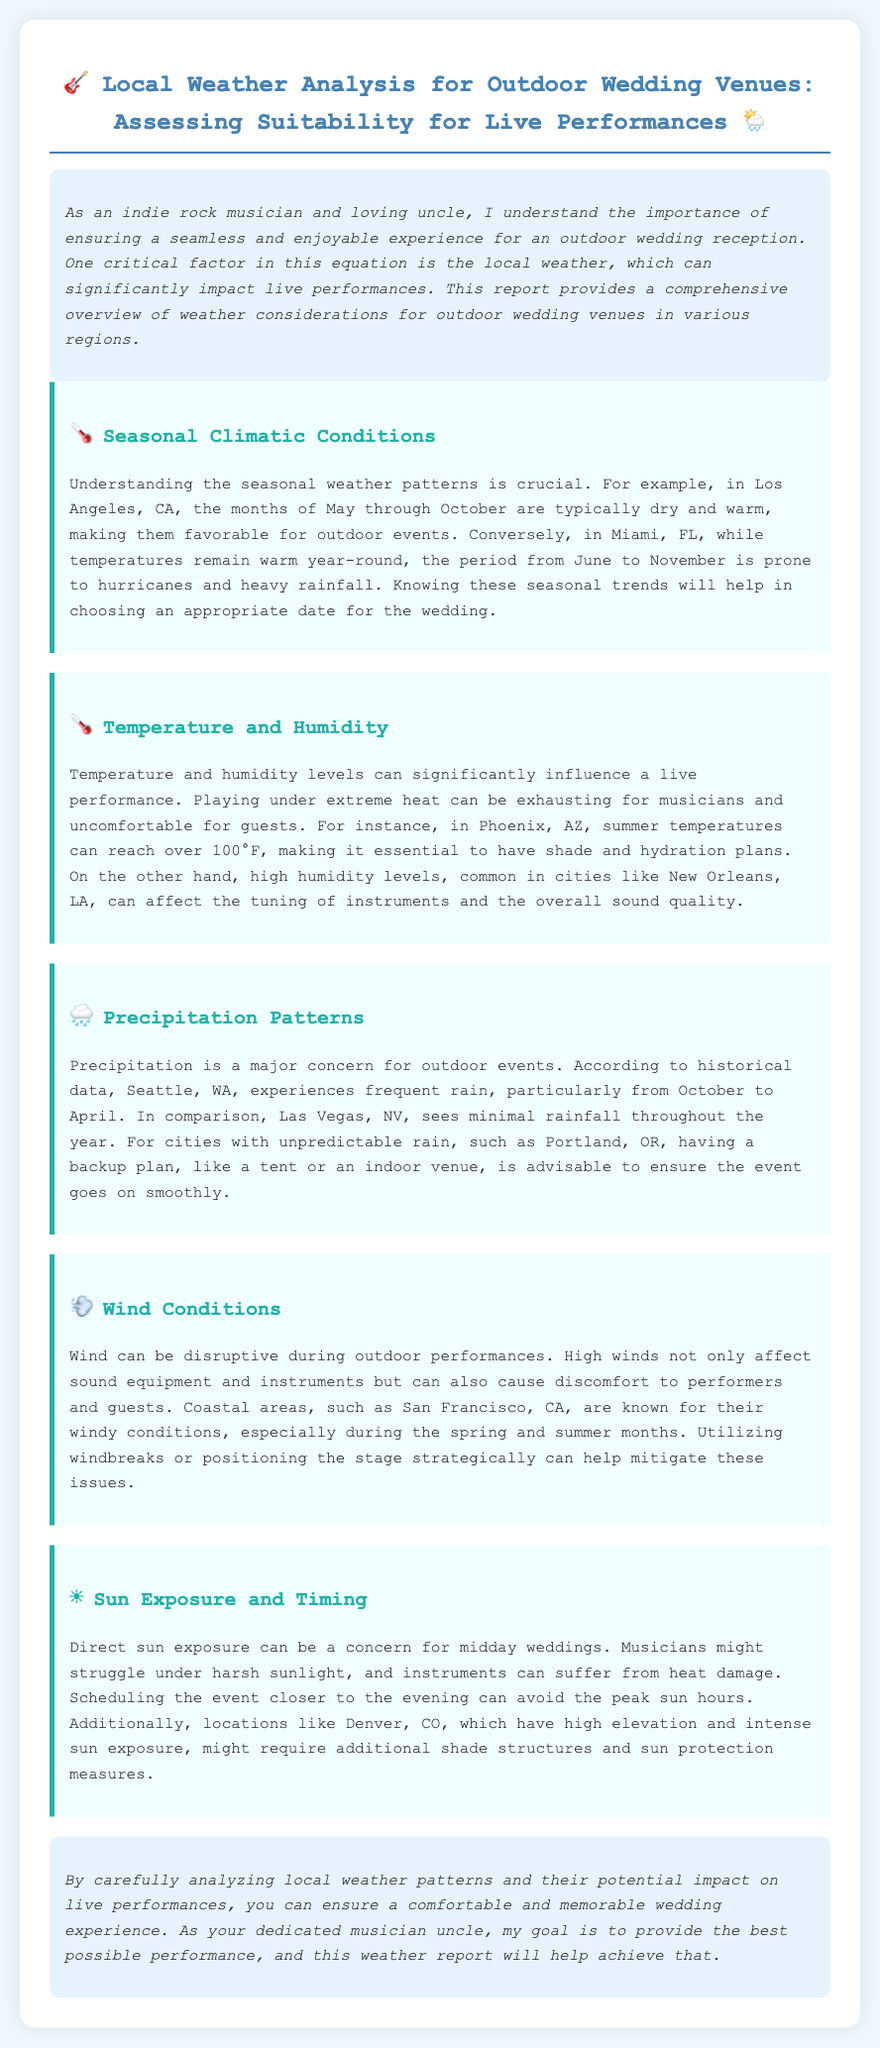What months are favorable for outdoor events in Los Angeles? The document states that the months of May through October are typically dry and warm in Los Angeles, making them favorable for outdoor events.
Answer: May through October Which city experiences frequent rain from October to April? The document notes that Seattle, WA experiences frequent rain, particularly from October to April.
Answer: Seattle What is a major concern for outdoor events according to the report? The report mentions that precipitation is a major concern for outdoor events.
Answer: Precipitation What can high humidity levels affect during live performances? The document indicates that high humidity levels can affect the tuning of instruments and the overall sound quality.
Answer: Tuning of instruments What should be considered for midday weddings? The document suggests that direct sun exposure can be a concern for midday weddings.
Answer: Direct sun exposure Which city's summers can reach over 100°F? The document specifies that Phoenix, AZ can reach over 100°F during the summer.
Answer: Phoenix What solutions are mentioned for windy conditions during performances? The document discusses utilizing windbreaks or positioning the stage strategically to mitigate wind effects.
Answer: Windbreaks Why is it advisable to have a backup plan in cities with unpredictable rain? Having a backup plan is advisable to ensure the event goes on smoothly in cities with unpredictable rain.
Answer: Backup plan What is the intent of this weather report? The document explains that the intent is to provide a comprehensive overview of weather considerations to ensure a comfortable and memorable wedding experience.
Answer: Comprehensive overview 